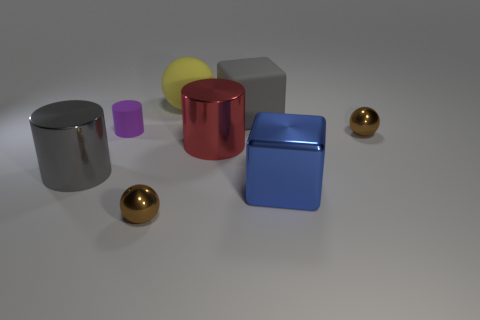Assuming the gray object on the right is a standard 8.5x11 inch sheet of paper, can you estimate the dimensions of the yellow sphere? If we assume the gray object is the size of standard letter paper, the yellow sphere adjacent to it might have a diameter of approximately 4 to 5 inches, based on its relative size to the paper's known dimensions. 